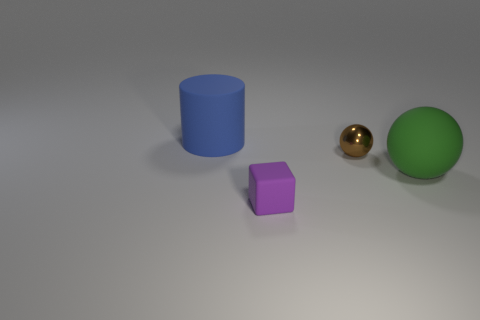Can you describe the materials the other objects might be made of? The blue cylinder appears to have a velvety, matte finish, suggesting it could be made of a non-reflective material like plastic or rubber. The purple cube has a slight sheen, which might indicate a material with a satin finish, such as painted wood or plastic. The green sphere, mentioned previously, seems to be made of rubber due to its dull, matte finish and muted color. 